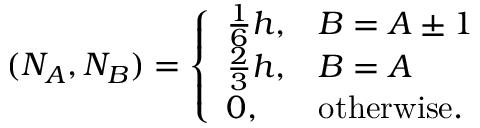<formula> <loc_0><loc_0><loc_500><loc_500>( N _ { A } , N _ { B } ) = \left \{ \begin{array} { l l } { \frac { 1 } { 6 } h , } & { B = A \pm 1 } \\ { \frac { 2 } { 3 } h , } & { B = A } \\ { 0 , } & { o t h e r w i s e . } \end{array}</formula> 